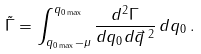<formula> <loc_0><loc_0><loc_500><loc_500>\tilde { \Gamma } = \int _ { q _ { 0 \max } - \mu } ^ { q _ { 0 \max } } \frac { d ^ { 2 } \Gamma } { d q _ { 0 } d \vec { q } \, ^ { 2 } } \, d q _ { 0 } \, .</formula> 